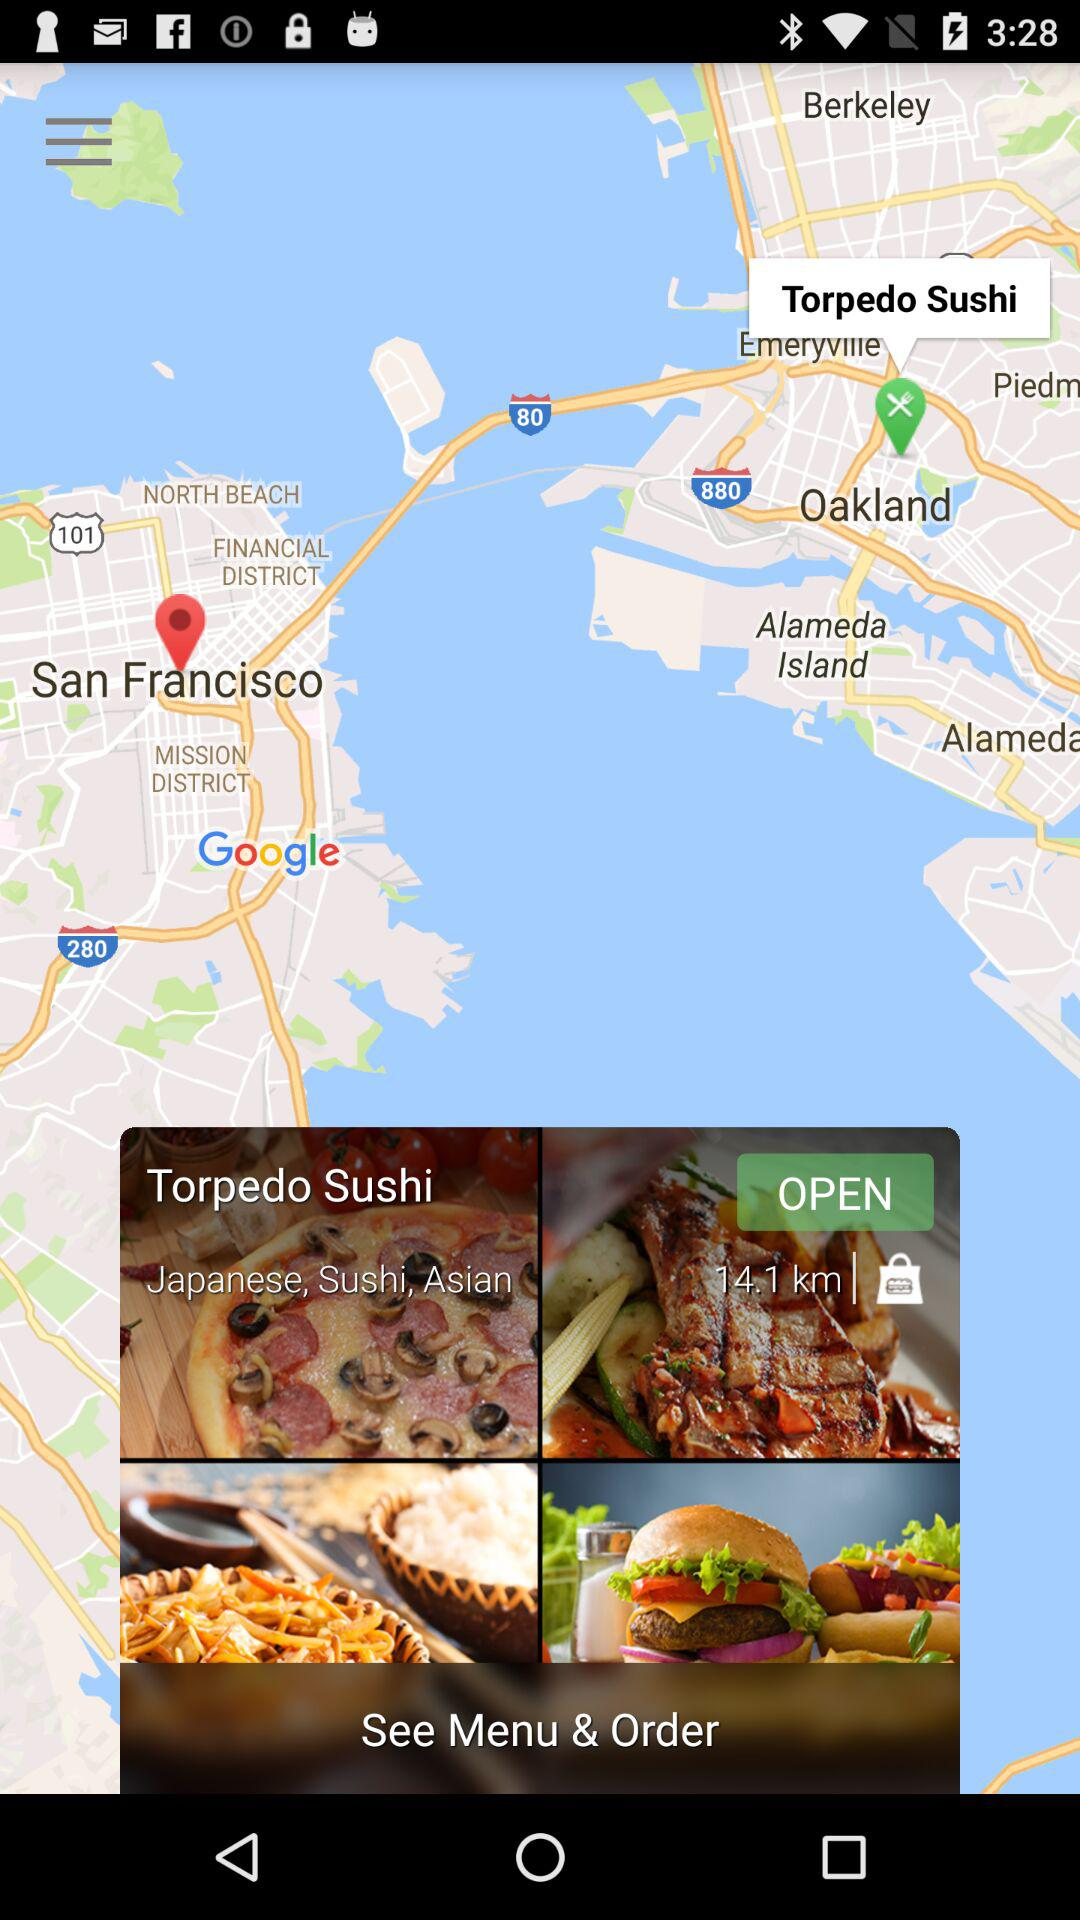What is the distance to the "Torpedo Sushi"? The distance is 14.1 km. 